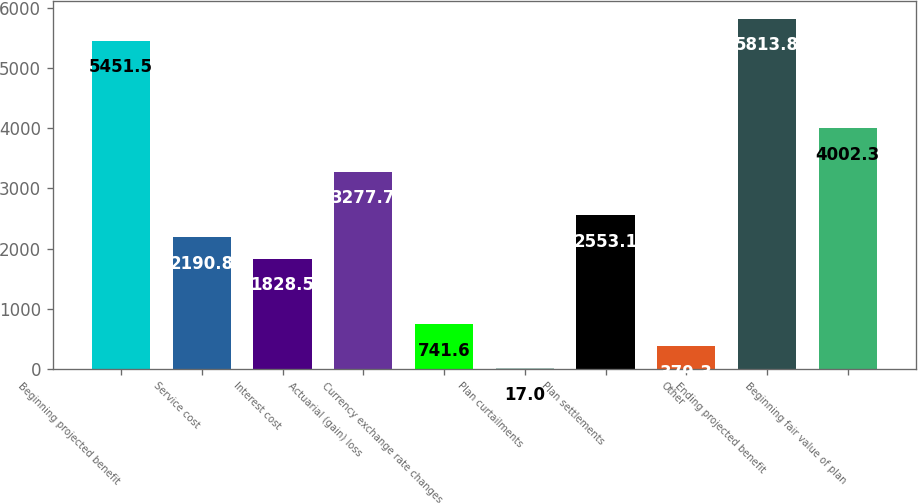<chart> <loc_0><loc_0><loc_500><loc_500><bar_chart><fcel>Beginning projected benefit<fcel>Service cost<fcel>Interest cost<fcel>Actuarial (gain) loss<fcel>Currency exchange rate changes<fcel>Plan curtailments<fcel>Plan settlements<fcel>Other<fcel>Ending projected benefit<fcel>Beginning fair value of plan<nl><fcel>5451.5<fcel>2190.8<fcel>1828.5<fcel>3277.7<fcel>741.6<fcel>17<fcel>2553.1<fcel>379.3<fcel>5813.8<fcel>4002.3<nl></chart> 